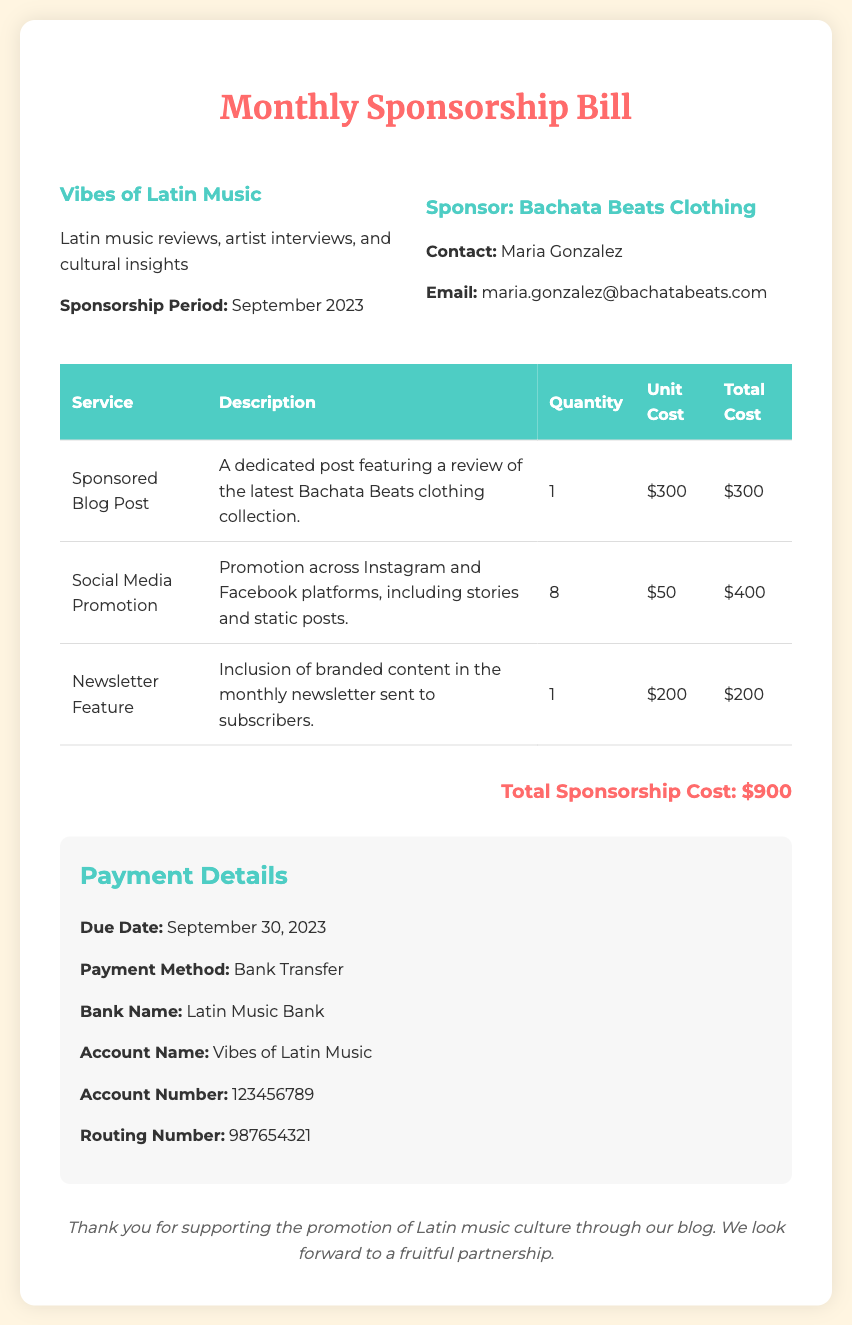What is the name of the blog? The blog is titled "Vibes of Latin Music".
Answer: Vibes of Latin Music Who is the sponsor? The sponsor listed in the document is Bachata Beats Clothing.
Answer: Bachata Beats Clothing What is the total sponsorship cost? The total sponsorship cost is calculated by adding up all the service costs, which is $900.
Answer: $900 When is the payment due? The due date for the payment is mentioned as September 30, 2023.
Answer: September 30, 2023 How many social media promotions were included? The number of social media promotions noted in the document is 8.
Answer: 8 What is the unit cost of a sponsored blog post? The document lists the unit cost of a sponsored blog post as $300.
Answer: $300 What payment method is specified? The payment method specified in the document is Bank Transfer.
Answer: Bank Transfer Which bank is mentioned for the payment? The bank mentioned for the payment in the document is Latin Music Bank.
Answer: Latin Music Bank What is included in the newsletter feature? The newsletter feature includes branded content as detailed in the document.
Answer: Branded content 